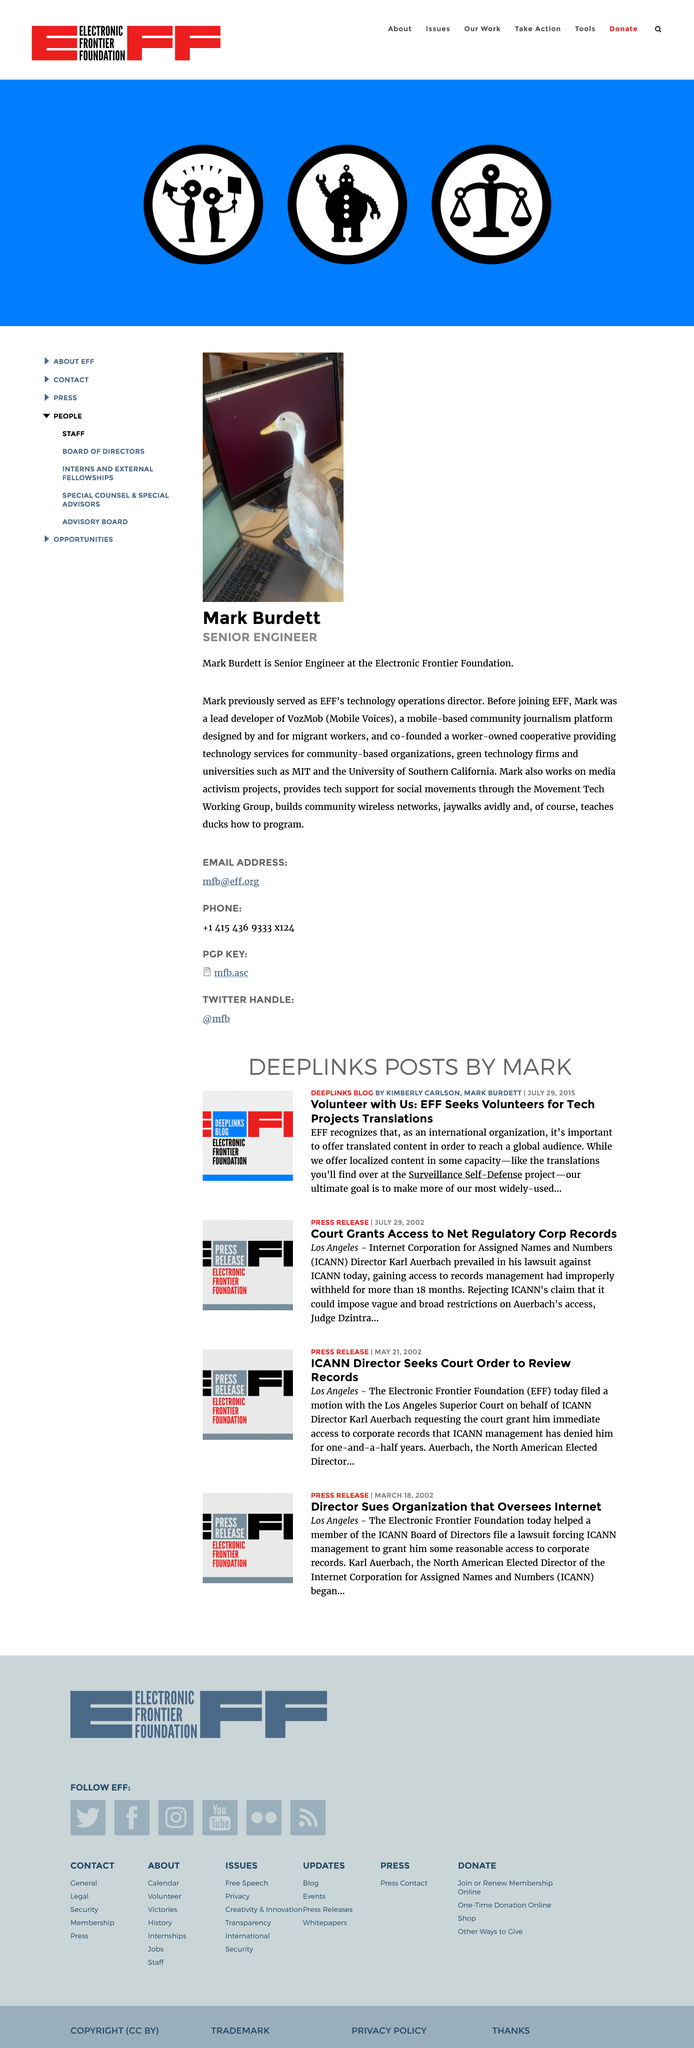Outline some significant characteristics in this image. Mark Burdett is a Senior Engineer at the Electronic Frontier Foundation who does a job that involves working with technology and contributing to the organization's mission to defend civil liberties in the digital world. Mark previously served as the technology operations director of the Electronic Frontier Foundation (EFF). Before joining the Electronic Frontier Foundation (EFF), Mark was a lead developer for VozMob (Mobile Voices), where he played a key role in advancing the organization's mission to promote social justice through mobile technology. 